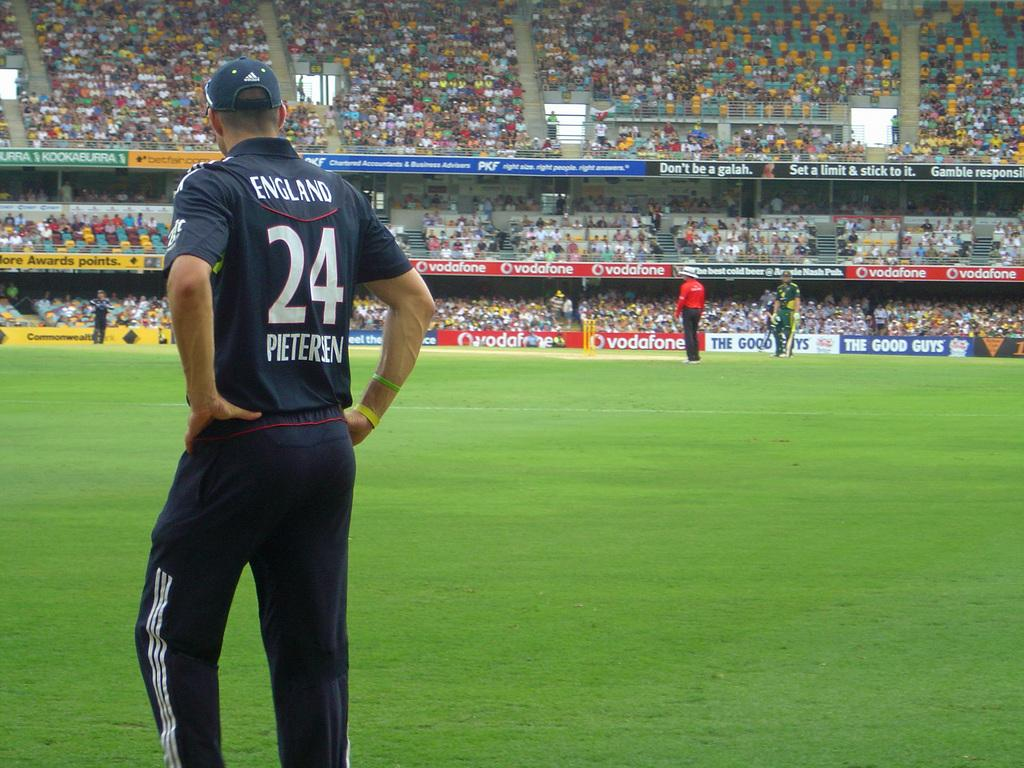<image>
Give a short and clear explanation of the subsequent image. the man is wearing an England 24 Pieteren jersey 